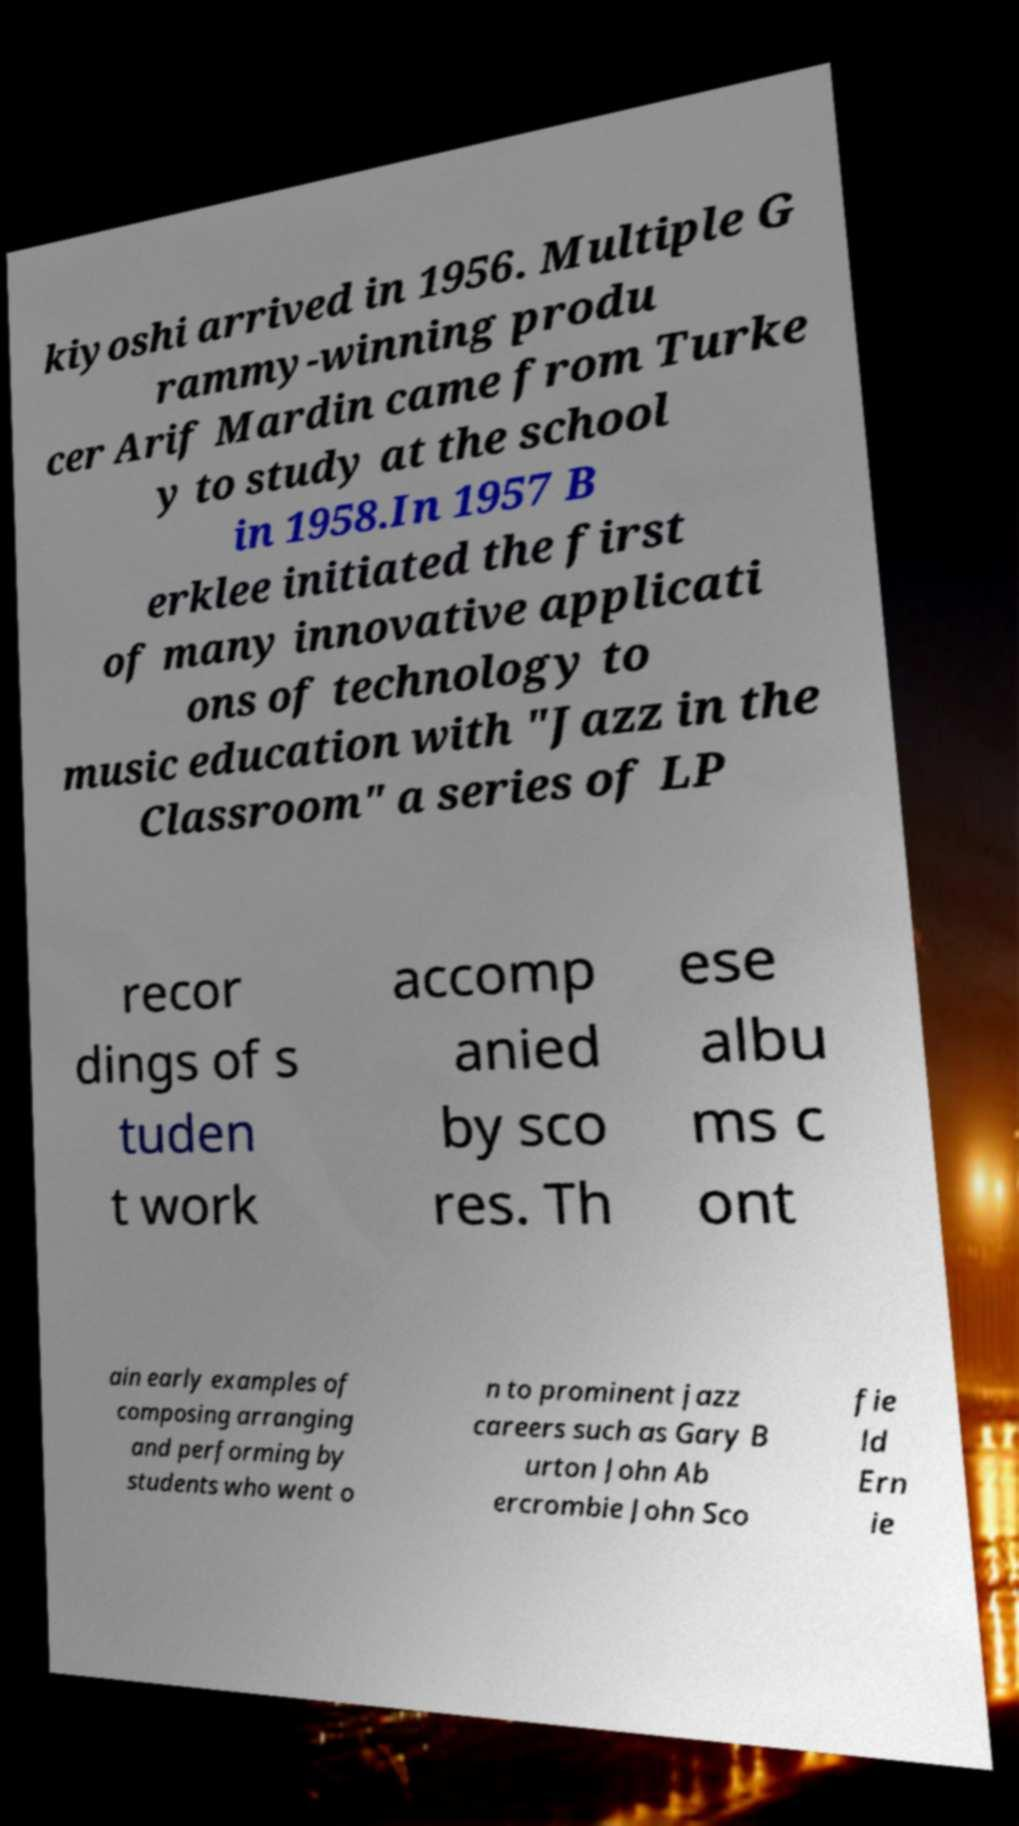I need the written content from this picture converted into text. Can you do that? kiyoshi arrived in 1956. Multiple G rammy-winning produ cer Arif Mardin came from Turke y to study at the school in 1958.In 1957 B erklee initiated the first of many innovative applicati ons of technology to music education with "Jazz in the Classroom" a series of LP recor dings of s tuden t work accomp anied by sco res. Th ese albu ms c ont ain early examples of composing arranging and performing by students who went o n to prominent jazz careers such as Gary B urton John Ab ercrombie John Sco fie ld Ern ie 